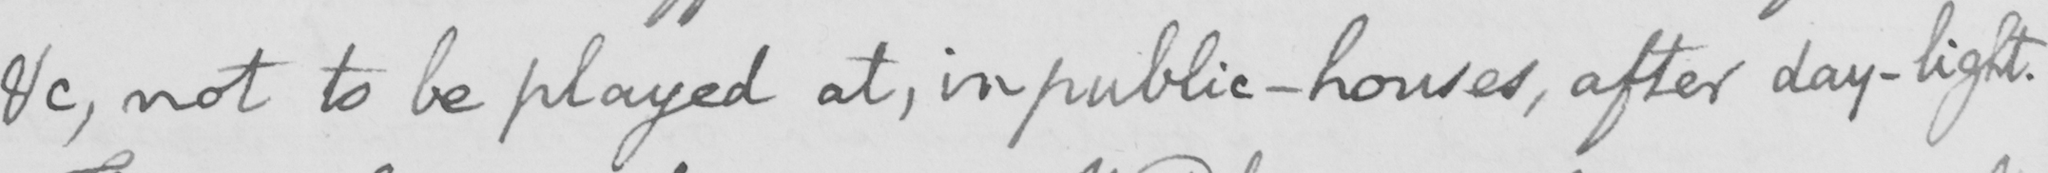Please transcribe the handwritten text in this image. &c , not to be played at , in public-houses , after day-light . 